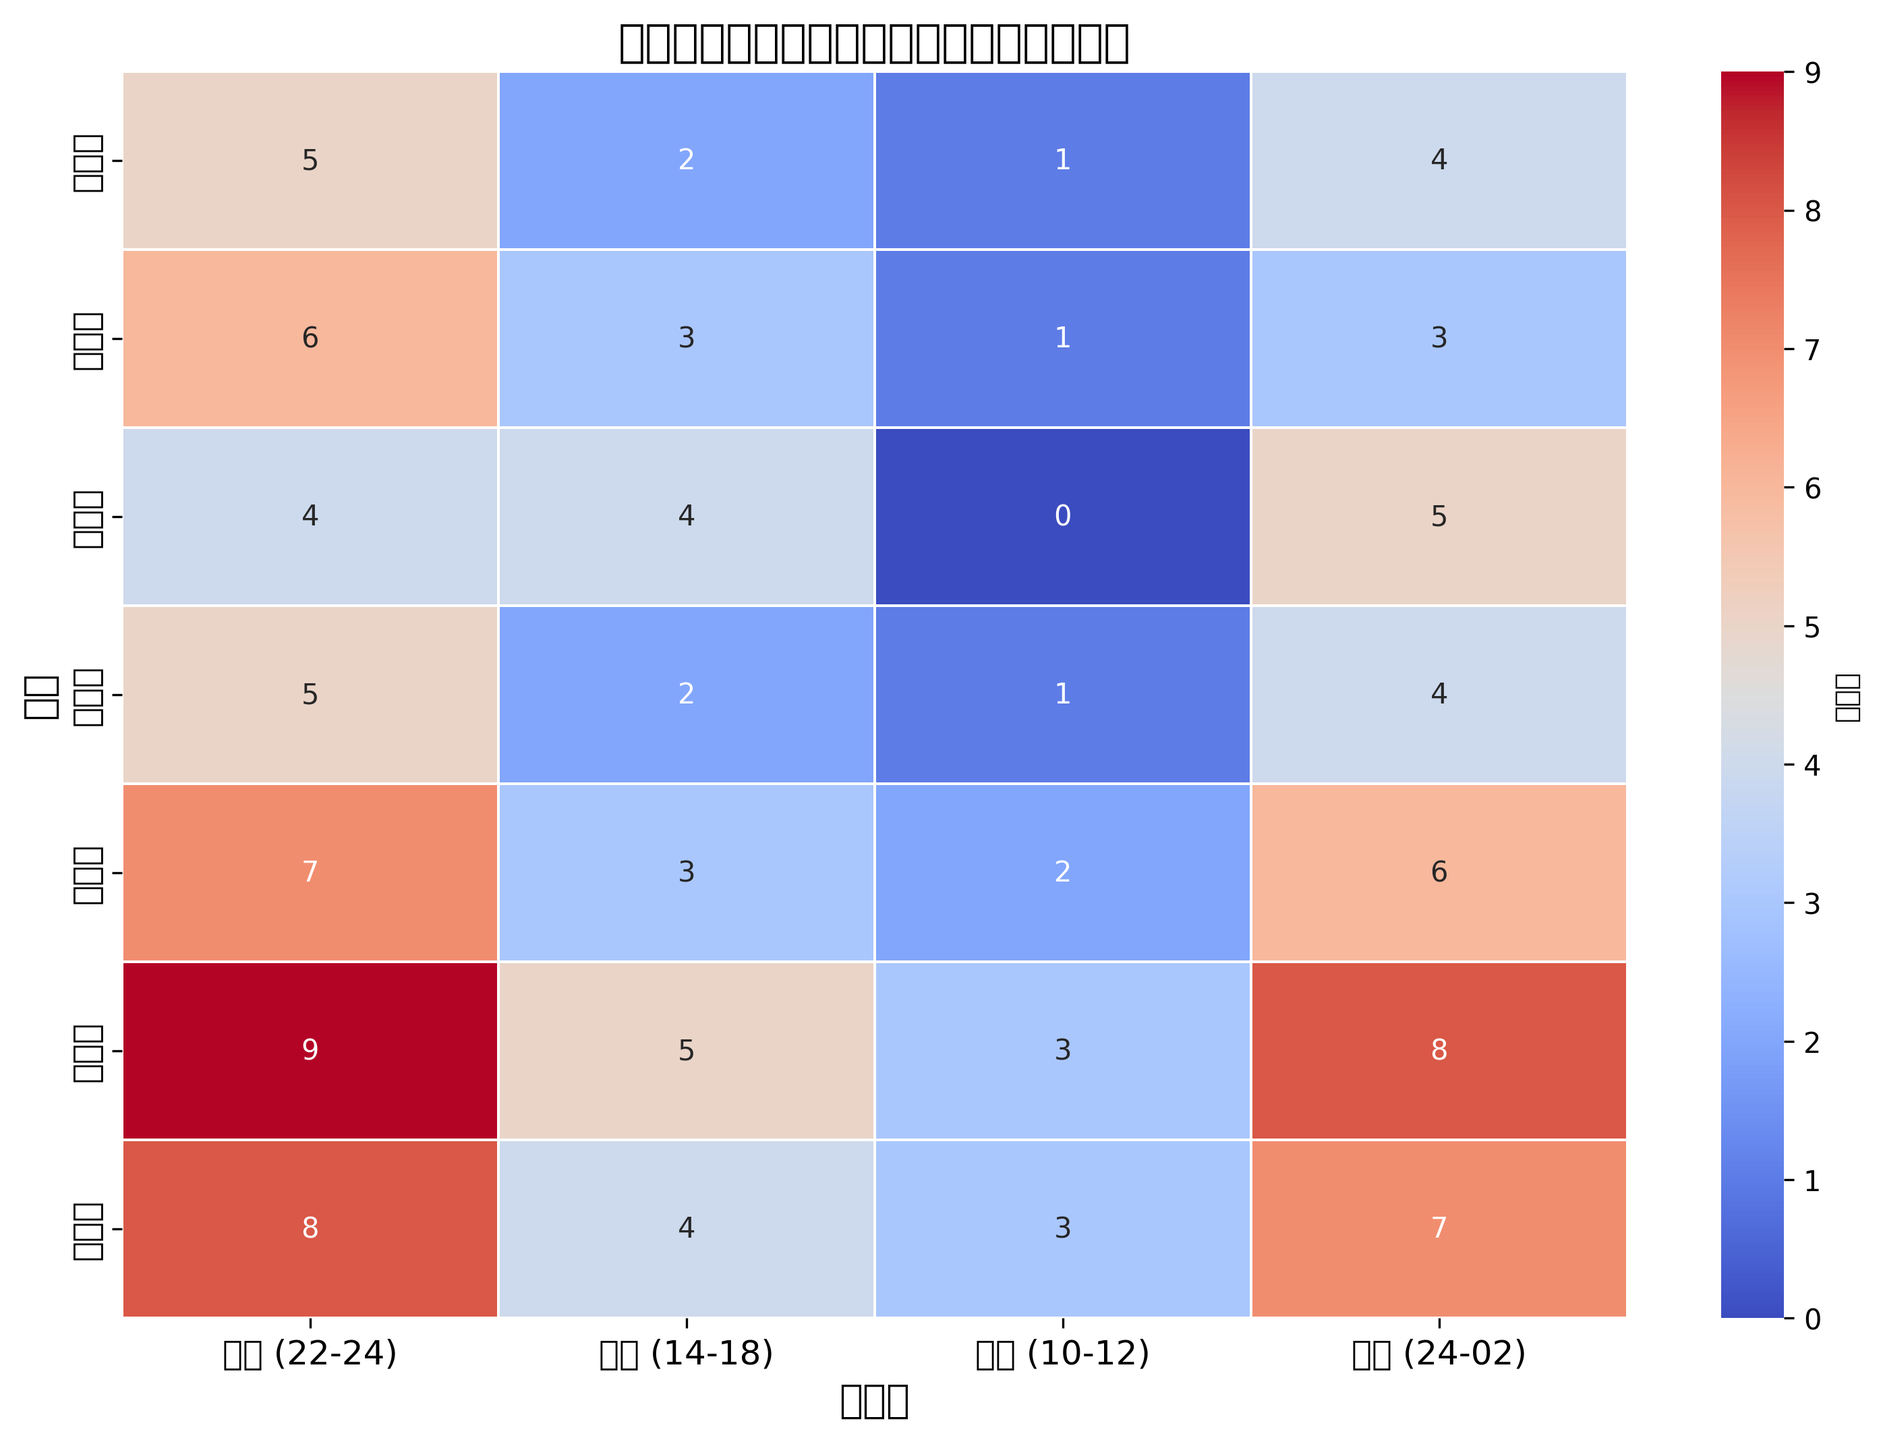Which day has the highest drama broadcast during the night (22-24)? Look at the column corresponding to the "夜间 (22-24)" time slot. Compare the values for each day to find the highest one. Saturday has 9 dramas, the highest value for this time slot.
Answer: Saturday Which time slot on Sunday has the lowest drama broadcast? Look at the row corresponding to Sunday and compare all the values in each time slot. The lowest value is 3 in both the "下午 (14-18)" and "上午 (10-12)" slots.
Answer: 下午 (14-18) and 上午 (10-12) What is the total number of drama broadcasts on Friday? Sum the values of all the time slots under the row for Friday: 7 (夜间) + 3 (下午) + 2 (上午) + 6 (凌晨) = 18.
Answer: 18 Which day has the least variance in drama broadcasts across different time slots? Calculate the variance for each day by finding the mean and then the squared differences from the mean. Compare the variances of all days. Wednesday has values 4, 4, 0, and 5, leading to a lower variance than other days.
Answer: Wednesday Compare the drama broadcast pattern of Monday and Thursday. Are there any similarities? Compare the number of dramas broadcast in each time slot for both Monday and Thursday. Both have the same number of dramas in each time slot: 5 (夜间), 2 (下午), 1 (上午), and 4 (凌晨).
Answer: Yes, they are the same Which time slot has the most variation in drama broadcasts throughout the week? Calculate the variance for each time slot by finding the mean and then the squared differences from the mean. The 夜间 (22-24) slot has the most variation, especially with high values such as 9 on Saturday and lower values on other days.
Answer: 夜间 (22-24) What is the average number of dramas broadcast during the morning (10-12) time slot? Sum the values of the "上午 (10-12)" column and divide by the number of days: (1 + 1 + 0 + 1 + 2 + 3 + 3) / 7 = 1.57.
Answer: 1.57 How do the drama broadcast counts on Saturday night (22-24) compare to Sunday night (22-24)? Look at the values in the "夜间 (22-24)" column for both Saturday and Sunday. Saturday has 9 broadcasts, and Sunday has 8 broadcasts. 9 > 8, so Saturday has more.
Answer: Saturday night (22-24) has more broadcasts than Sunday night (22-24) On which day is the drama viewership least concentrated in a single time slot? Look for the day with the most even distribution across time slots. Wednesday has close values (4, 4, 0, 5), suggesting a less concentrated viewership compared to other days where single time slots dominate.
Answer: Wednesday 